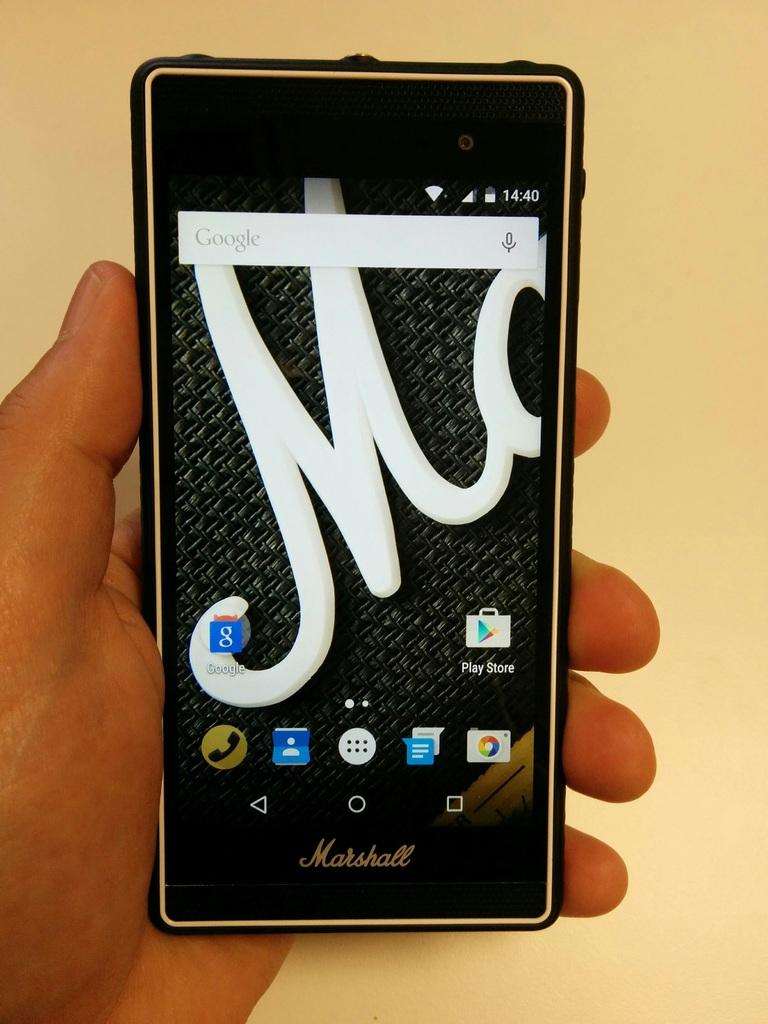Provide a one-sentence caption for the provided image. A Marshall phone displays a large M as the background screen image. 